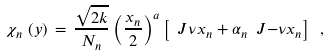Convert formula to latex. <formula><loc_0><loc_0><loc_500><loc_500>\chi _ { n } \, \left ( y \right ) \, = \, \frac { \sqrt { 2 k } } { N _ { n } } \left ( \frac { x _ { n } } { 2 } \right ) ^ { a } \left [ \ J { \nu } { x _ { n } } + \alpha _ { n } \ J { - \nu } { x _ { n } } \right ] \ ,</formula> 